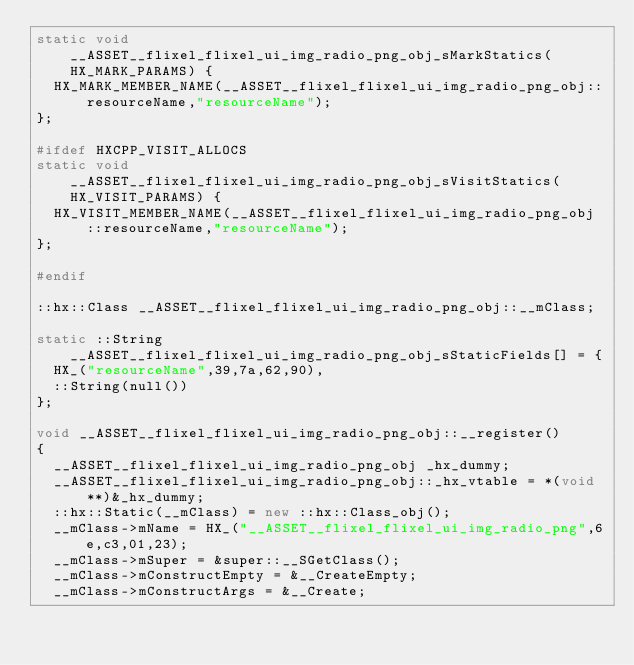<code> <loc_0><loc_0><loc_500><loc_500><_C++_>static void __ASSET__flixel_flixel_ui_img_radio_png_obj_sMarkStatics(HX_MARK_PARAMS) {
	HX_MARK_MEMBER_NAME(__ASSET__flixel_flixel_ui_img_radio_png_obj::resourceName,"resourceName");
};

#ifdef HXCPP_VISIT_ALLOCS
static void __ASSET__flixel_flixel_ui_img_radio_png_obj_sVisitStatics(HX_VISIT_PARAMS) {
	HX_VISIT_MEMBER_NAME(__ASSET__flixel_flixel_ui_img_radio_png_obj::resourceName,"resourceName");
};

#endif

::hx::Class __ASSET__flixel_flixel_ui_img_radio_png_obj::__mClass;

static ::String __ASSET__flixel_flixel_ui_img_radio_png_obj_sStaticFields[] = {
	HX_("resourceName",39,7a,62,90),
	::String(null())
};

void __ASSET__flixel_flixel_ui_img_radio_png_obj::__register()
{
	__ASSET__flixel_flixel_ui_img_radio_png_obj _hx_dummy;
	__ASSET__flixel_flixel_ui_img_radio_png_obj::_hx_vtable = *(void **)&_hx_dummy;
	::hx::Static(__mClass) = new ::hx::Class_obj();
	__mClass->mName = HX_("__ASSET__flixel_flixel_ui_img_radio_png",6e,c3,01,23);
	__mClass->mSuper = &super::__SGetClass();
	__mClass->mConstructEmpty = &__CreateEmpty;
	__mClass->mConstructArgs = &__Create;</code> 